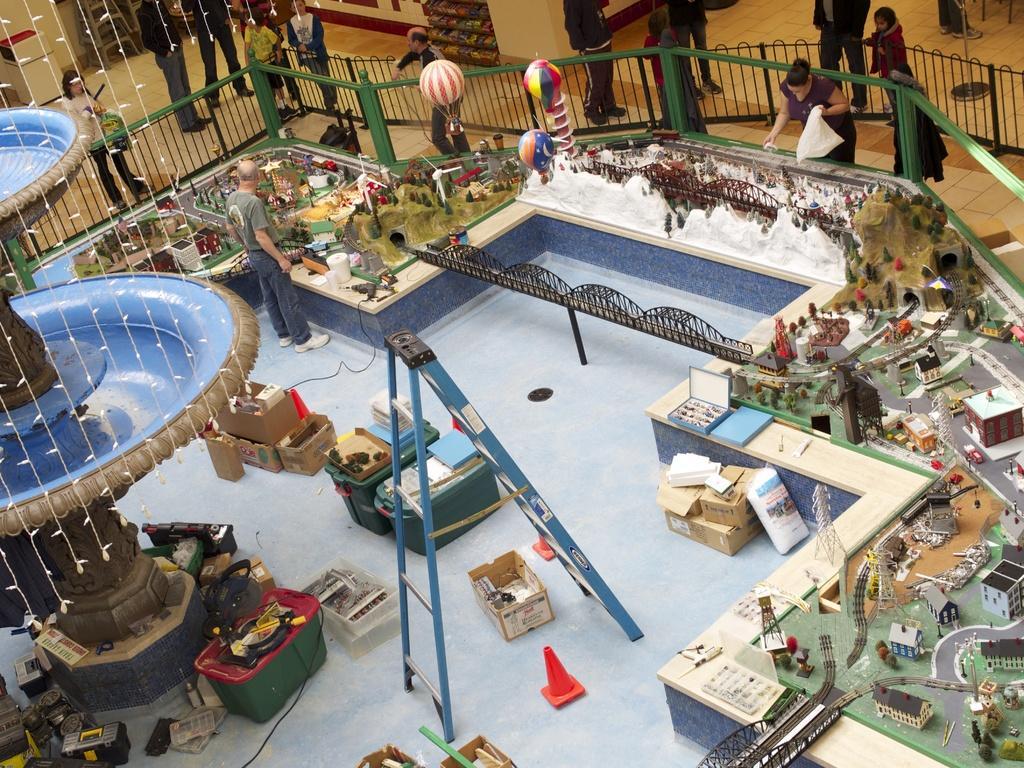In one or two sentences, can you explain what this image depicts? In this picture we can see the top view of the miniature city with some buildings, train tracks, suspension bridge, snow mountains and trees. On the left side there is a man, standing and looking at the miniature city. Behind there is a green fencing grill and some people standing and looking. On the left corner we can see the blue water fountain, ladder and tool box.  